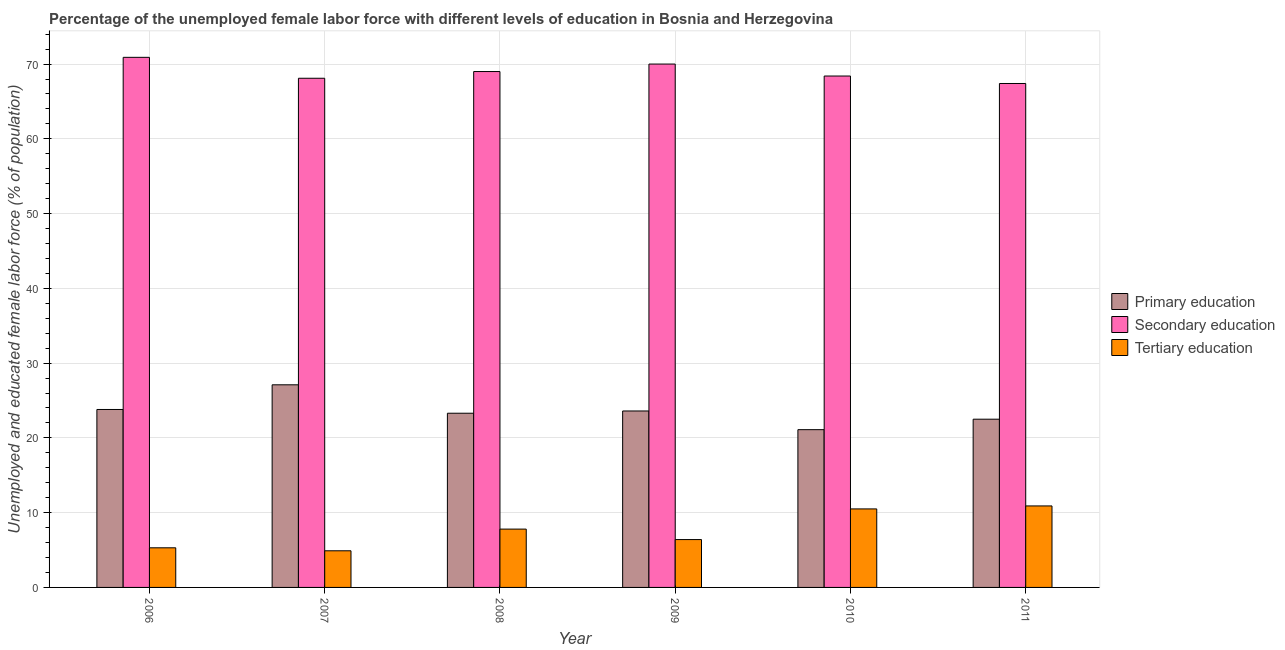Are the number of bars per tick equal to the number of legend labels?
Your response must be concise. Yes. Are the number of bars on each tick of the X-axis equal?
Provide a succinct answer. Yes. How many bars are there on the 3rd tick from the right?
Ensure brevity in your answer.  3. What is the label of the 6th group of bars from the left?
Provide a short and direct response. 2011. What is the percentage of female labor force who received secondary education in 2007?
Offer a terse response. 68.1. Across all years, what is the maximum percentage of female labor force who received primary education?
Offer a very short reply. 27.1. Across all years, what is the minimum percentage of female labor force who received tertiary education?
Provide a short and direct response. 4.9. In which year was the percentage of female labor force who received tertiary education maximum?
Offer a terse response. 2011. What is the total percentage of female labor force who received tertiary education in the graph?
Offer a terse response. 45.8. What is the difference between the percentage of female labor force who received tertiary education in 2010 and that in 2011?
Provide a short and direct response. -0.4. What is the difference between the percentage of female labor force who received secondary education in 2006 and the percentage of female labor force who received tertiary education in 2009?
Provide a succinct answer. 0.9. What is the average percentage of female labor force who received secondary education per year?
Offer a terse response. 68.97. What is the ratio of the percentage of female labor force who received tertiary education in 2008 to that in 2010?
Offer a terse response. 0.74. Is the percentage of female labor force who received primary education in 2007 less than that in 2011?
Your answer should be very brief. No. What is the difference between the highest and the second highest percentage of female labor force who received primary education?
Give a very brief answer. 3.3. What is the difference between the highest and the lowest percentage of female labor force who received secondary education?
Provide a short and direct response. 3.5. In how many years, is the percentage of female labor force who received secondary education greater than the average percentage of female labor force who received secondary education taken over all years?
Your response must be concise. 3. What does the 2nd bar from the left in 2010 represents?
Keep it short and to the point. Secondary education. What does the 1st bar from the right in 2006 represents?
Provide a succinct answer. Tertiary education. Is it the case that in every year, the sum of the percentage of female labor force who received primary education and percentage of female labor force who received secondary education is greater than the percentage of female labor force who received tertiary education?
Your answer should be compact. Yes. How many bars are there?
Your response must be concise. 18. How many years are there in the graph?
Keep it short and to the point. 6. What is the difference between two consecutive major ticks on the Y-axis?
Offer a very short reply. 10. Are the values on the major ticks of Y-axis written in scientific E-notation?
Provide a short and direct response. No. Does the graph contain grids?
Your answer should be very brief. Yes. Where does the legend appear in the graph?
Offer a terse response. Center right. How are the legend labels stacked?
Ensure brevity in your answer.  Vertical. What is the title of the graph?
Ensure brevity in your answer.  Percentage of the unemployed female labor force with different levels of education in Bosnia and Herzegovina. What is the label or title of the X-axis?
Offer a very short reply. Year. What is the label or title of the Y-axis?
Provide a succinct answer. Unemployed and educated female labor force (% of population). What is the Unemployed and educated female labor force (% of population) of Primary education in 2006?
Provide a succinct answer. 23.8. What is the Unemployed and educated female labor force (% of population) of Secondary education in 2006?
Keep it short and to the point. 70.9. What is the Unemployed and educated female labor force (% of population) in Tertiary education in 2006?
Make the answer very short. 5.3. What is the Unemployed and educated female labor force (% of population) in Primary education in 2007?
Provide a succinct answer. 27.1. What is the Unemployed and educated female labor force (% of population) in Secondary education in 2007?
Make the answer very short. 68.1. What is the Unemployed and educated female labor force (% of population) in Tertiary education in 2007?
Make the answer very short. 4.9. What is the Unemployed and educated female labor force (% of population) in Primary education in 2008?
Your answer should be compact. 23.3. What is the Unemployed and educated female labor force (% of population) of Tertiary education in 2008?
Your answer should be very brief. 7.8. What is the Unemployed and educated female labor force (% of population) of Primary education in 2009?
Provide a short and direct response. 23.6. What is the Unemployed and educated female labor force (% of population) of Secondary education in 2009?
Your answer should be very brief. 70. What is the Unemployed and educated female labor force (% of population) of Tertiary education in 2009?
Keep it short and to the point. 6.4. What is the Unemployed and educated female labor force (% of population) in Primary education in 2010?
Offer a terse response. 21.1. What is the Unemployed and educated female labor force (% of population) of Secondary education in 2010?
Ensure brevity in your answer.  68.4. What is the Unemployed and educated female labor force (% of population) of Primary education in 2011?
Provide a short and direct response. 22.5. What is the Unemployed and educated female labor force (% of population) of Secondary education in 2011?
Your answer should be compact. 67.4. What is the Unemployed and educated female labor force (% of population) of Tertiary education in 2011?
Your answer should be very brief. 10.9. Across all years, what is the maximum Unemployed and educated female labor force (% of population) in Primary education?
Provide a short and direct response. 27.1. Across all years, what is the maximum Unemployed and educated female labor force (% of population) of Secondary education?
Your answer should be very brief. 70.9. Across all years, what is the maximum Unemployed and educated female labor force (% of population) in Tertiary education?
Ensure brevity in your answer.  10.9. Across all years, what is the minimum Unemployed and educated female labor force (% of population) of Primary education?
Keep it short and to the point. 21.1. Across all years, what is the minimum Unemployed and educated female labor force (% of population) of Secondary education?
Offer a terse response. 67.4. Across all years, what is the minimum Unemployed and educated female labor force (% of population) of Tertiary education?
Provide a succinct answer. 4.9. What is the total Unemployed and educated female labor force (% of population) of Primary education in the graph?
Offer a terse response. 141.4. What is the total Unemployed and educated female labor force (% of population) of Secondary education in the graph?
Offer a terse response. 413.8. What is the total Unemployed and educated female labor force (% of population) in Tertiary education in the graph?
Provide a short and direct response. 45.8. What is the difference between the Unemployed and educated female labor force (% of population) in Tertiary education in 2006 and that in 2007?
Make the answer very short. 0.4. What is the difference between the Unemployed and educated female labor force (% of population) in Primary education in 2006 and that in 2008?
Provide a succinct answer. 0.5. What is the difference between the Unemployed and educated female labor force (% of population) of Tertiary education in 2006 and that in 2008?
Give a very brief answer. -2.5. What is the difference between the Unemployed and educated female labor force (% of population) of Primary education in 2006 and that in 2009?
Make the answer very short. 0.2. What is the difference between the Unemployed and educated female labor force (% of population) in Secondary education in 2006 and that in 2009?
Give a very brief answer. 0.9. What is the difference between the Unemployed and educated female labor force (% of population) in Primary education in 2006 and that in 2010?
Give a very brief answer. 2.7. What is the difference between the Unemployed and educated female labor force (% of population) in Tertiary education in 2006 and that in 2010?
Provide a succinct answer. -5.2. What is the difference between the Unemployed and educated female labor force (% of population) in Tertiary education in 2007 and that in 2008?
Provide a succinct answer. -2.9. What is the difference between the Unemployed and educated female labor force (% of population) of Tertiary education in 2007 and that in 2009?
Your answer should be compact. -1.5. What is the difference between the Unemployed and educated female labor force (% of population) of Secondary education in 2007 and that in 2010?
Provide a succinct answer. -0.3. What is the difference between the Unemployed and educated female labor force (% of population) in Secondary education in 2007 and that in 2011?
Give a very brief answer. 0.7. What is the difference between the Unemployed and educated female labor force (% of population) in Tertiary education in 2007 and that in 2011?
Your response must be concise. -6. What is the difference between the Unemployed and educated female labor force (% of population) of Primary education in 2008 and that in 2009?
Make the answer very short. -0.3. What is the difference between the Unemployed and educated female labor force (% of population) in Secondary education in 2008 and that in 2009?
Make the answer very short. -1. What is the difference between the Unemployed and educated female labor force (% of population) in Primary education in 2008 and that in 2010?
Offer a terse response. 2.2. What is the difference between the Unemployed and educated female labor force (% of population) of Secondary education in 2008 and that in 2010?
Keep it short and to the point. 0.6. What is the difference between the Unemployed and educated female labor force (% of population) in Primary education in 2008 and that in 2011?
Provide a succinct answer. 0.8. What is the difference between the Unemployed and educated female labor force (% of population) of Secondary education in 2008 and that in 2011?
Provide a short and direct response. 1.6. What is the difference between the Unemployed and educated female labor force (% of population) of Tertiary education in 2008 and that in 2011?
Ensure brevity in your answer.  -3.1. What is the difference between the Unemployed and educated female labor force (% of population) in Primary education in 2009 and that in 2010?
Make the answer very short. 2.5. What is the difference between the Unemployed and educated female labor force (% of population) in Tertiary education in 2009 and that in 2011?
Your answer should be very brief. -4.5. What is the difference between the Unemployed and educated female labor force (% of population) in Primary education in 2010 and that in 2011?
Ensure brevity in your answer.  -1.4. What is the difference between the Unemployed and educated female labor force (% of population) in Secondary education in 2010 and that in 2011?
Your answer should be compact. 1. What is the difference between the Unemployed and educated female labor force (% of population) of Primary education in 2006 and the Unemployed and educated female labor force (% of population) of Secondary education in 2007?
Offer a very short reply. -44.3. What is the difference between the Unemployed and educated female labor force (% of population) of Primary education in 2006 and the Unemployed and educated female labor force (% of population) of Tertiary education in 2007?
Provide a short and direct response. 18.9. What is the difference between the Unemployed and educated female labor force (% of population) of Secondary education in 2006 and the Unemployed and educated female labor force (% of population) of Tertiary education in 2007?
Make the answer very short. 66. What is the difference between the Unemployed and educated female labor force (% of population) of Primary education in 2006 and the Unemployed and educated female labor force (% of population) of Secondary education in 2008?
Provide a succinct answer. -45.2. What is the difference between the Unemployed and educated female labor force (% of population) in Primary education in 2006 and the Unemployed and educated female labor force (% of population) in Tertiary education in 2008?
Offer a terse response. 16. What is the difference between the Unemployed and educated female labor force (% of population) in Secondary education in 2006 and the Unemployed and educated female labor force (% of population) in Tertiary education in 2008?
Offer a very short reply. 63.1. What is the difference between the Unemployed and educated female labor force (% of population) in Primary education in 2006 and the Unemployed and educated female labor force (% of population) in Secondary education in 2009?
Give a very brief answer. -46.2. What is the difference between the Unemployed and educated female labor force (% of population) in Primary education in 2006 and the Unemployed and educated female labor force (% of population) in Tertiary education in 2009?
Keep it short and to the point. 17.4. What is the difference between the Unemployed and educated female labor force (% of population) in Secondary education in 2006 and the Unemployed and educated female labor force (% of population) in Tertiary education in 2009?
Give a very brief answer. 64.5. What is the difference between the Unemployed and educated female labor force (% of population) of Primary education in 2006 and the Unemployed and educated female labor force (% of population) of Secondary education in 2010?
Give a very brief answer. -44.6. What is the difference between the Unemployed and educated female labor force (% of population) in Primary education in 2006 and the Unemployed and educated female labor force (% of population) in Tertiary education in 2010?
Keep it short and to the point. 13.3. What is the difference between the Unemployed and educated female labor force (% of population) in Secondary education in 2006 and the Unemployed and educated female labor force (% of population) in Tertiary education in 2010?
Offer a very short reply. 60.4. What is the difference between the Unemployed and educated female labor force (% of population) in Primary education in 2006 and the Unemployed and educated female labor force (% of population) in Secondary education in 2011?
Offer a terse response. -43.6. What is the difference between the Unemployed and educated female labor force (% of population) of Primary education in 2007 and the Unemployed and educated female labor force (% of population) of Secondary education in 2008?
Offer a very short reply. -41.9. What is the difference between the Unemployed and educated female labor force (% of population) in Primary education in 2007 and the Unemployed and educated female labor force (% of population) in Tertiary education in 2008?
Keep it short and to the point. 19.3. What is the difference between the Unemployed and educated female labor force (% of population) of Secondary education in 2007 and the Unemployed and educated female labor force (% of population) of Tertiary education in 2008?
Offer a very short reply. 60.3. What is the difference between the Unemployed and educated female labor force (% of population) of Primary education in 2007 and the Unemployed and educated female labor force (% of population) of Secondary education in 2009?
Provide a succinct answer. -42.9. What is the difference between the Unemployed and educated female labor force (% of population) in Primary education in 2007 and the Unemployed and educated female labor force (% of population) in Tertiary education in 2009?
Offer a very short reply. 20.7. What is the difference between the Unemployed and educated female labor force (% of population) in Secondary education in 2007 and the Unemployed and educated female labor force (% of population) in Tertiary education in 2009?
Your response must be concise. 61.7. What is the difference between the Unemployed and educated female labor force (% of population) in Primary education in 2007 and the Unemployed and educated female labor force (% of population) in Secondary education in 2010?
Keep it short and to the point. -41.3. What is the difference between the Unemployed and educated female labor force (% of population) in Primary education in 2007 and the Unemployed and educated female labor force (% of population) in Tertiary education in 2010?
Ensure brevity in your answer.  16.6. What is the difference between the Unemployed and educated female labor force (% of population) in Secondary education in 2007 and the Unemployed and educated female labor force (% of population) in Tertiary education in 2010?
Give a very brief answer. 57.6. What is the difference between the Unemployed and educated female labor force (% of population) of Primary education in 2007 and the Unemployed and educated female labor force (% of population) of Secondary education in 2011?
Offer a terse response. -40.3. What is the difference between the Unemployed and educated female labor force (% of population) in Secondary education in 2007 and the Unemployed and educated female labor force (% of population) in Tertiary education in 2011?
Make the answer very short. 57.2. What is the difference between the Unemployed and educated female labor force (% of population) in Primary education in 2008 and the Unemployed and educated female labor force (% of population) in Secondary education in 2009?
Offer a terse response. -46.7. What is the difference between the Unemployed and educated female labor force (% of population) in Secondary education in 2008 and the Unemployed and educated female labor force (% of population) in Tertiary education in 2009?
Provide a succinct answer. 62.6. What is the difference between the Unemployed and educated female labor force (% of population) in Primary education in 2008 and the Unemployed and educated female labor force (% of population) in Secondary education in 2010?
Provide a short and direct response. -45.1. What is the difference between the Unemployed and educated female labor force (% of population) in Primary education in 2008 and the Unemployed and educated female labor force (% of population) in Tertiary education in 2010?
Offer a very short reply. 12.8. What is the difference between the Unemployed and educated female labor force (% of population) in Secondary education in 2008 and the Unemployed and educated female labor force (% of population) in Tertiary education in 2010?
Give a very brief answer. 58.5. What is the difference between the Unemployed and educated female labor force (% of population) of Primary education in 2008 and the Unemployed and educated female labor force (% of population) of Secondary education in 2011?
Offer a very short reply. -44.1. What is the difference between the Unemployed and educated female labor force (% of population) in Primary education in 2008 and the Unemployed and educated female labor force (% of population) in Tertiary education in 2011?
Make the answer very short. 12.4. What is the difference between the Unemployed and educated female labor force (% of population) in Secondary education in 2008 and the Unemployed and educated female labor force (% of population) in Tertiary education in 2011?
Offer a terse response. 58.1. What is the difference between the Unemployed and educated female labor force (% of population) of Primary education in 2009 and the Unemployed and educated female labor force (% of population) of Secondary education in 2010?
Make the answer very short. -44.8. What is the difference between the Unemployed and educated female labor force (% of population) in Secondary education in 2009 and the Unemployed and educated female labor force (% of population) in Tertiary education in 2010?
Your answer should be compact. 59.5. What is the difference between the Unemployed and educated female labor force (% of population) in Primary education in 2009 and the Unemployed and educated female labor force (% of population) in Secondary education in 2011?
Provide a short and direct response. -43.8. What is the difference between the Unemployed and educated female labor force (% of population) in Secondary education in 2009 and the Unemployed and educated female labor force (% of population) in Tertiary education in 2011?
Your response must be concise. 59.1. What is the difference between the Unemployed and educated female labor force (% of population) in Primary education in 2010 and the Unemployed and educated female labor force (% of population) in Secondary education in 2011?
Your answer should be compact. -46.3. What is the difference between the Unemployed and educated female labor force (% of population) of Secondary education in 2010 and the Unemployed and educated female labor force (% of population) of Tertiary education in 2011?
Provide a short and direct response. 57.5. What is the average Unemployed and educated female labor force (% of population) of Primary education per year?
Offer a very short reply. 23.57. What is the average Unemployed and educated female labor force (% of population) in Secondary education per year?
Your response must be concise. 68.97. What is the average Unemployed and educated female labor force (% of population) in Tertiary education per year?
Make the answer very short. 7.63. In the year 2006, what is the difference between the Unemployed and educated female labor force (% of population) of Primary education and Unemployed and educated female labor force (% of population) of Secondary education?
Provide a succinct answer. -47.1. In the year 2006, what is the difference between the Unemployed and educated female labor force (% of population) in Secondary education and Unemployed and educated female labor force (% of population) in Tertiary education?
Your response must be concise. 65.6. In the year 2007, what is the difference between the Unemployed and educated female labor force (% of population) of Primary education and Unemployed and educated female labor force (% of population) of Secondary education?
Keep it short and to the point. -41. In the year 2007, what is the difference between the Unemployed and educated female labor force (% of population) in Primary education and Unemployed and educated female labor force (% of population) in Tertiary education?
Your answer should be very brief. 22.2. In the year 2007, what is the difference between the Unemployed and educated female labor force (% of population) of Secondary education and Unemployed and educated female labor force (% of population) of Tertiary education?
Your response must be concise. 63.2. In the year 2008, what is the difference between the Unemployed and educated female labor force (% of population) of Primary education and Unemployed and educated female labor force (% of population) of Secondary education?
Ensure brevity in your answer.  -45.7. In the year 2008, what is the difference between the Unemployed and educated female labor force (% of population) of Secondary education and Unemployed and educated female labor force (% of population) of Tertiary education?
Offer a terse response. 61.2. In the year 2009, what is the difference between the Unemployed and educated female labor force (% of population) of Primary education and Unemployed and educated female labor force (% of population) of Secondary education?
Your answer should be very brief. -46.4. In the year 2009, what is the difference between the Unemployed and educated female labor force (% of population) in Secondary education and Unemployed and educated female labor force (% of population) in Tertiary education?
Keep it short and to the point. 63.6. In the year 2010, what is the difference between the Unemployed and educated female labor force (% of population) in Primary education and Unemployed and educated female labor force (% of population) in Secondary education?
Ensure brevity in your answer.  -47.3. In the year 2010, what is the difference between the Unemployed and educated female labor force (% of population) in Primary education and Unemployed and educated female labor force (% of population) in Tertiary education?
Keep it short and to the point. 10.6. In the year 2010, what is the difference between the Unemployed and educated female labor force (% of population) in Secondary education and Unemployed and educated female labor force (% of population) in Tertiary education?
Give a very brief answer. 57.9. In the year 2011, what is the difference between the Unemployed and educated female labor force (% of population) of Primary education and Unemployed and educated female labor force (% of population) of Secondary education?
Make the answer very short. -44.9. In the year 2011, what is the difference between the Unemployed and educated female labor force (% of population) of Primary education and Unemployed and educated female labor force (% of population) of Tertiary education?
Provide a succinct answer. 11.6. In the year 2011, what is the difference between the Unemployed and educated female labor force (% of population) in Secondary education and Unemployed and educated female labor force (% of population) in Tertiary education?
Give a very brief answer. 56.5. What is the ratio of the Unemployed and educated female labor force (% of population) in Primary education in 2006 to that in 2007?
Offer a terse response. 0.88. What is the ratio of the Unemployed and educated female labor force (% of population) in Secondary education in 2006 to that in 2007?
Provide a short and direct response. 1.04. What is the ratio of the Unemployed and educated female labor force (% of population) of Tertiary education in 2006 to that in 2007?
Give a very brief answer. 1.08. What is the ratio of the Unemployed and educated female labor force (% of population) of Primary education in 2006 to that in 2008?
Your answer should be compact. 1.02. What is the ratio of the Unemployed and educated female labor force (% of population) in Secondary education in 2006 to that in 2008?
Give a very brief answer. 1.03. What is the ratio of the Unemployed and educated female labor force (% of population) in Tertiary education in 2006 to that in 2008?
Provide a succinct answer. 0.68. What is the ratio of the Unemployed and educated female labor force (% of population) of Primary education in 2006 to that in 2009?
Make the answer very short. 1.01. What is the ratio of the Unemployed and educated female labor force (% of population) of Secondary education in 2006 to that in 2009?
Your answer should be compact. 1.01. What is the ratio of the Unemployed and educated female labor force (% of population) in Tertiary education in 2006 to that in 2009?
Your answer should be very brief. 0.83. What is the ratio of the Unemployed and educated female labor force (% of population) of Primary education in 2006 to that in 2010?
Offer a terse response. 1.13. What is the ratio of the Unemployed and educated female labor force (% of population) of Secondary education in 2006 to that in 2010?
Offer a terse response. 1.04. What is the ratio of the Unemployed and educated female labor force (% of population) of Tertiary education in 2006 to that in 2010?
Keep it short and to the point. 0.5. What is the ratio of the Unemployed and educated female labor force (% of population) of Primary education in 2006 to that in 2011?
Ensure brevity in your answer.  1.06. What is the ratio of the Unemployed and educated female labor force (% of population) of Secondary education in 2006 to that in 2011?
Ensure brevity in your answer.  1.05. What is the ratio of the Unemployed and educated female labor force (% of population) in Tertiary education in 2006 to that in 2011?
Offer a terse response. 0.49. What is the ratio of the Unemployed and educated female labor force (% of population) in Primary education in 2007 to that in 2008?
Keep it short and to the point. 1.16. What is the ratio of the Unemployed and educated female labor force (% of population) in Tertiary education in 2007 to that in 2008?
Make the answer very short. 0.63. What is the ratio of the Unemployed and educated female labor force (% of population) of Primary education in 2007 to that in 2009?
Your answer should be compact. 1.15. What is the ratio of the Unemployed and educated female labor force (% of population) of Secondary education in 2007 to that in 2009?
Make the answer very short. 0.97. What is the ratio of the Unemployed and educated female labor force (% of population) of Tertiary education in 2007 to that in 2009?
Your answer should be very brief. 0.77. What is the ratio of the Unemployed and educated female labor force (% of population) in Primary education in 2007 to that in 2010?
Your answer should be compact. 1.28. What is the ratio of the Unemployed and educated female labor force (% of population) of Tertiary education in 2007 to that in 2010?
Provide a succinct answer. 0.47. What is the ratio of the Unemployed and educated female labor force (% of population) of Primary education in 2007 to that in 2011?
Your answer should be very brief. 1.2. What is the ratio of the Unemployed and educated female labor force (% of population) in Secondary education in 2007 to that in 2011?
Keep it short and to the point. 1.01. What is the ratio of the Unemployed and educated female labor force (% of population) in Tertiary education in 2007 to that in 2011?
Your response must be concise. 0.45. What is the ratio of the Unemployed and educated female labor force (% of population) of Primary education in 2008 to that in 2009?
Provide a short and direct response. 0.99. What is the ratio of the Unemployed and educated female labor force (% of population) of Secondary education in 2008 to that in 2009?
Your answer should be very brief. 0.99. What is the ratio of the Unemployed and educated female labor force (% of population) of Tertiary education in 2008 to that in 2009?
Give a very brief answer. 1.22. What is the ratio of the Unemployed and educated female labor force (% of population) of Primary education in 2008 to that in 2010?
Provide a short and direct response. 1.1. What is the ratio of the Unemployed and educated female labor force (% of population) in Secondary education in 2008 to that in 2010?
Ensure brevity in your answer.  1.01. What is the ratio of the Unemployed and educated female labor force (% of population) in Tertiary education in 2008 to that in 2010?
Provide a short and direct response. 0.74. What is the ratio of the Unemployed and educated female labor force (% of population) of Primary education in 2008 to that in 2011?
Your answer should be very brief. 1.04. What is the ratio of the Unemployed and educated female labor force (% of population) in Secondary education in 2008 to that in 2011?
Offer a very short reply. 1.02. What is the ratio of the Unemployed and educated female labor force (% of population) of Tertiary education in 2008 to that in 2011?
Ensure brevity in your answer.  0.72. What is the ratio of the Unemployed and educated female labor force (% of population) in Primary education in 2009 to that in 2010?
Keep it short and to the point. 1.12. What is the ratio of the Unemployed and educated female labor force (% of population) in Secondary education in 2009 to that in 2010?
Make the answer very short. 1.02. What is the ratio of the Unemployed and educated female labor force (% of population) in Tertiary education in 2009 to that in 2010?
Provide a succinct answer. 0.61. What is the ratio of the Unemployed and educated female labor force (% of population) in Primary education in 2009 to that in 2011?
Provide a succinct answer. 1.05. What is the ratio of the Unemployed and educated female labor force (% of population) in Secondary education in 2009 to that in 2011?
Provide a succinct answer. 1.04. What is the ratio of the Unemployed and educated female labor force (% of population) in Tertiary education in 2009 to that in 2011?
Offer a very short reply. 0.59. What is the ratio of the Unemployed and educated female labor force (% of population) in Primary education in 2010 to that in 2011?
Give a very brief answer. 0.94. What is the ratio of the Unemployed and educated female labor force (% of population) in Secondary education in 2010 to that in 2011?
Provide a short and direct response. 1.01. What is the ratio of the Unemployed and educated female labor force (% of population) in Tertiary education in 2010 to that in 2011?
Make the answer very short. 0.96. What is the difference between the highest and the second highest Unemployed and educated female labor force (% of population) in Primary education?
Your answer should be very brief. 3.3. What is the difference between the highest and the second highest Unemployed and educated female labor force (% of population) in Tertiary education?
Make the answer very short. 0.4. What is the difference between the highest and the lowest Unemployed and educated female labor force (% of population) in Primary education?
Offer a terse response. 6. What is the difference between the highest and the lowest Unemployed and educated female labor force (% of population) of Secondary education?
Provide a succinct answer. 3.5. What is the difference between the highest and the lowest Unemployed and educated female labor force (% of population) in Tertiary education?
Offer a terse response. 6. 